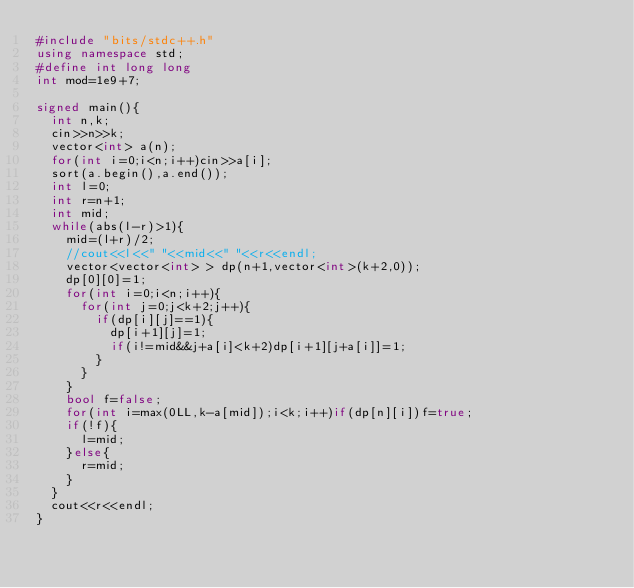Convert code to text. <code><loc_0><loc_0><loc_500><loc_500><_C++_>#include "bits/stdc++.h"
using namespace std;
#define int long long
int mod=1e9+7;

signed main(){
  int n,k;
  cin>>n>>k;
  vector<int> a(n);
  for(int i=0;i<n;i++)cin>>a[i];
  sort(a.begin(),a.end());
  int l=0;
  int r=n+1;
  int mid;
  while(abs(l-r)>1){
    mid=(l+r)/2;
    //cout<<l<<" "<<mid<<" "<<r<<endl;
    vector<vector<int> > dp(n+1,vector<int>(k+2,0));
    dp[0][0]=1;
    for(int i=0;i<n;i++){
      for(int j=0;j<k+2;j++){
        if(dp[i][j]==1){
          dp[i+1][j]=1;
          if(i!=mid&&j+a[i]<k+2)dp[i+1][j+a[i]]=1;
        }
      }
    }
    bool f=false;
    for(int i=max(0LL,k-a[mid]);i<k;i++)if(dp[n][i])f=true;
    if(!f){
      l=mid;
    }else{
      r=mid;
    }
  }
  cout<<r<<endl;
}
</code> 